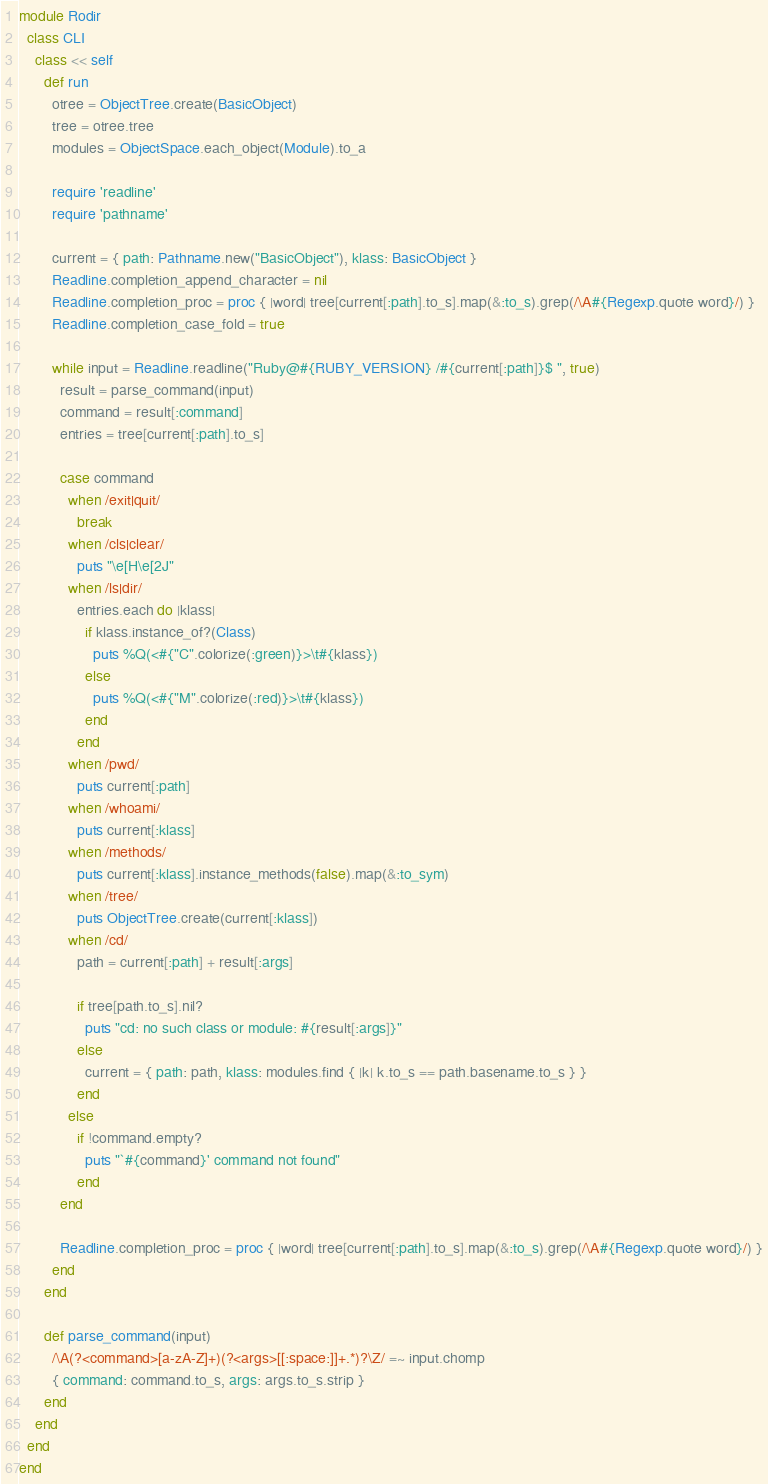<code> <loc_0><loc_0><loc_500><loc_500><_Ruby_>module Rodir
  class CLI
    class << self
      def run
        otree = ObjectTree.create(BasicObject)
        tree = otree.tree
        modules = ObjectSpace.each_object(Module).to_a

        require 'readline'
        require 'pathname'

        current = { path: Pathname.new("BasicObject"), klass: BasicObject }
        Readline.completion_append_character = nil
        Readline.completion_proc = proc { |word| tree[current[:path].to_s].map(&:to_s).grep(/\A#{Regexp.quote word}/) }
        Readline.completion_case_fold = true

        while input = Readline.readline("Ruby@#{RUBY_VERSION} /#{current[:path]}$ ", true)
          result = parse_command(input)
          command = result[:command]
          entries = tree[current[:path].to_s]

          case command
            when /exit|quit/
              break
            when /cls|clear/
              puts "\e[H\e[2J"
            when /ls|dir/
              entries.each do |klass|
                if klass.instance_of?(Class)
                  puts %Q(<#{"C".colorize(:green)}>\t#{klass})
                else
                  puts %Q(<#{"M".colorize(:red)}>\t#{klass})
                end
              end
            when /pwd/
              puts current[:path]
            when /whoami/
              puts current[:klass]
            when /methods/
              puts current[:klass].instance_methods(false).map(&:to_sym)
            when /tree/
              puts ObjectTree.create(current[:klass])
            when /cd/
              path = current[:path] + result[:args]

              if tree[path.to_s].nil?
                puts "cd: no such class or module: #{result[:args]}"
              else
                current = { path: path, klass: modules.find { |k| k.to_s == path.basename.to_s } }
              end
            else
              if !command.empty?
                puts "`#{command}' command not found"
              end
          end

          Readline.completion_proc = proc { |word| tree[current[:path].to_s].map(&:to_s).grep(/\A#{Regexp.quote word}/) }
        end
      end

      def parse_command(input)
        /\A(?<command>[a-zA-Z]+)(?<args>[[:space:]]+.*)?\Z/ =~ input.chomp
        { command: command.to_s, args: args.to_s.strip }
      end
    end
  end
end
</code> 